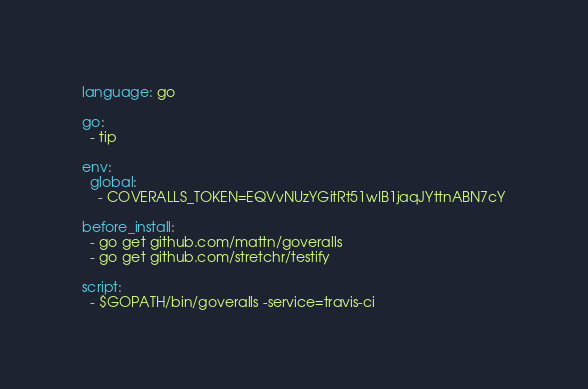Convert code to text. <code><loc_0><loc_0><loc_500><loc_500><_YAML_>language: go

go:
  - tip

env:
  global:
    - COVERALLS_TOKEN=EQVvNUzYGitRt51wIB1jaqJYttnABN7cY

before_install:
  - go get github.com/mattn/goveralls
  - go get github.com/stretchr/testify

script:
  - $GOPATH/bin/goveralls -service=travis-ci
</code> 